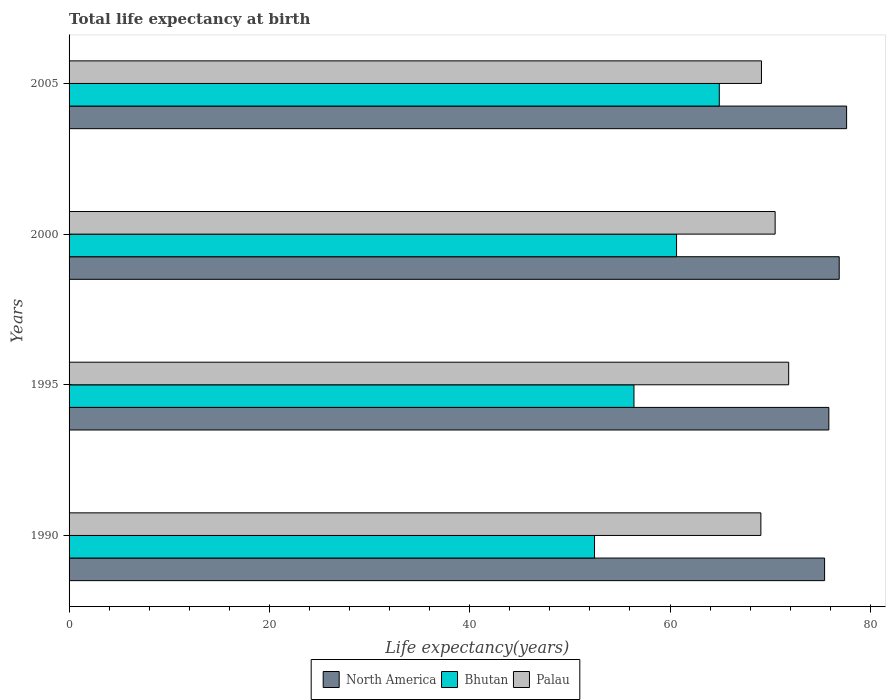Are the number of bars on each tick of the Y-axis equal?
Your answer should be very brief. Yes. What is the life expectancy at birth in in Bhutan in 1995?
Your answer should be very brief. 56.4. Across all years, what is the maximum life expectancy at birth in in Palau?
Ensure brevity in your answer.  71.84. Across all years, what is the minimum life expectancy at birth in in Palau?
Your answer should be very brief. 69.07. In which year was the life expectancy at birth in in North America maximum?
Make the answer very short. 2005. In which year was the life expectancy at birth in in North America minimum?
Make the answer very short. 1990. What is the total life expectancy at birth in in North America in the graph?
Your answer should be compact. 305.81. What is the difference between the life expectancy at birth in in Palau in 1990 and that in 2000?
Your response must be concise. -1.42. What is the difference between the life expectancy at birth in in Palau in 1990 and the life expectancy at birth in in Bhutan in 2005?
Offer a terse response. 4.15. What is the average life expectancy at birth in in Bhutan per year?
Offer a terse response. 58.61. In the year 1990, what is the difference between the life expectancy at birth in in North America and life expectancy at birth in in Bhutan?
Your answer should be compact. 22.97. What is the ratio of the life expectancy at birth in in Palau in 2000 to that in 2005?
Keep it short and to the point. 1.02. Is the life expectancy at birth in in Palau in 1995 less than that in 2000?
Your answer should be very brief. No. What is the difference between the highest and the second highest life expectancy at birth in in North America?
Give a very brief answer. 0.74. What is the difference between the highest and the lowest life expectancy at birth in in North America?
Give a very brief answer. 2.2. In how many years, is the life expectancy at birth in in Palau greater than the average life expectancy at birth in in Palau taken over all years?
Offer a very short reply. 2. Is the sum of the life expectancy at birth in in North America in 2000 and 2005 greater than the maximum life expectancy at birth in in Bhutan across all years?
Provide a short and direct response. Yes. Is it the case that in every year, the sum of the life expectancy at birth in in Palau and life expectancy at birth in in North America is greater than the life expectancy at birth in in Bhutan?
Your response must be concise. Yes. Does the graph contain any zero values?
Your answer should be compact. No. Does the graph contain grids?
Ensure brevity in your answer.  No. How many legend labels are there?
Your response must be concise. 3. How are the legend labels stacked?
Provide a succinct answer. Horizontal. What is the title of the graph?
Provide a short and direct response. Total life expectancy at birth. What is the label or title of the X-axis?
Ensure brevity in your answer.  Life expectancy(years). What is the Life expectancy(years) of North America in 1990?
Offer a very short reply. 75.43. What is the Life expectancy(years) of Bhutan in 1990?
Provide a short and direct response. 52.46. What is the Life expectancy(years) of Palau in 1990?
Your answer should be very brief. 69.07. What is the Life expectancy(years) in North America in 1995?
Provide a short and direct response. 75.86. What is the Life expectancy(years) of Bhutan in 1995?
Make the answer very short. 56.4. What is the Life expectancy(years) of Palau in 1995?
Provide a short and direct response. 71.84. What is the Life expectancy(years) of North America in 2000?
Provide a succinct answer. 76.89. What is the Life expectancy(years) in Bhutan in 2000?
Offer a terse response. 60.65. What is the Life expectancy(years) in Palau in 2000?
Provide a short and direct response. 70.49. What is the Life expectancy(years) of North America in 2005?
Your response must be concise. 77.63. What is the Life expectancy(years) of Bhutan in 2005?
Your answer should be very brief. 64.92. What is the Life expectancy(years) in Palau in 2005?
Your response must be concise. 69.13. Across all years, what is the maximum Life expectancy(years) of North America?
Provide a succinct answer. 77.63. Across all years, what is the maximum Life expectancy(years) in Bhutan?
Offer a terse response. 64.92. Across all years, what is the maximum Life expectancy(years) of Palau?
Your answer should be compact. 71.84. Across all years, what is the minimum Life expectancy(years) of North America?
Your response must be concise. 75.43. Across all years, what is the minimum Life expectancy(years) in Bhutan?
Provide a succinct answer. 52.46. Across all years, what is the minimum Life expectancy(years) in Palau?
Ensure brevity in your answer.  69.07. What is the total Life expectancy(years) of North America in the graph?
Provide a short and direct response. 305.81. What is the total Life expectancy(years) in Bhutan in the graph?
Make the answer very short. 234.43. What is the total Life expectancy(years) in Palau in the graph?
Your answer should be compact. 280.54. What is the difference between the Life expectancy(years) in North America in 1990 and that in 1995?
Your answer should be very brief. -0.42. What is the difference between the Life expectancy(years) of Bhutan in 1990 and that in 1995?
Ensure brevity in your answer.  -3.94. What is the difference between the Life expectancy(years) in Palau in 1990 and that in 1995?
Offer a terse response. -2.78. What is the difference between the Life expectancy(years) in North America in 1990 and that in 2000?
Your answer should be compact. -1.46. What is the difference between the Life expectancy(years) of Bhutan in 1990 and that in 2000?
Offer a very short reply. -8.19. What is the difference between the Life expectancy(years) in Palau in 1990 and that in 2000?
Provide a short and direct response. -1.42. What is the difference between the Life expectancy(years) of North America in 1990 and that in 2005?
Your answer should be very brief. -2.2. What is the difference between the Life expectancy(years) in Bhutan in 1990 and that in 2005?
Ensure brevity in your answer.  -12.46. What is the difference between the Life expectancy(years) in Palau in 1990 and that in 2005?
Provide a succinct answer. -0.06. What is the difference between the Life expectancy(years) of North America in 1995 and that in 2000?
Your response must be concise. -1.04. What is the difference between the Life expectancy(years) in Bhutan in 1995 and that in 2000?
Give a very brief answer. -4.25. What is the difference between the Life expectancy(years) of Palau in 1995 and that in 2000?
Give a very brief answer. 1.35. What is the difference between the Life expectancy(years) of North America in 1995 and that in 2005?
Ensure brevity in your answer.  -1.77. What is the difference between the Life expectancy(years) of Bhutan in 1995 and that in 2005?
Make the answer very short. -8.52. What is the difference between the Life expectancy(years) of Palau in 1995 and that in 2005?
Offer a terse response. 2.72. What is the difference between the Life expectancy(years) of North America in 2000 and that in 2005?
Your answer should be compact. -0.74. What is the difference between the Life expectancy(years) in Bhutan in 2000 and that in 2005?
Provide a short and direct response. -4.27. What is the difference between the Life expectancy(years) in Palau in 2000 and that in 2005?
Your response must be concise. 1.36. What is the difference between the Life expectancy(years) in North America in 1990 and the Life expectancy(years) in Bhutan in 1995?
Your answer should be very brief. 19.03. What is the difference between the Life expectancy(years) of North America in 1990 and the Life expectancy(years) of Palau in 1995?
Offer a terse response. 3.59. What is the difference between the Life expectancy(years) in Bhutan in 1990 and the Life expectancy(years) in Palau in 1995?
Make the answer very short. -19.38. What is the difference between the Life expectancy(years) in North America in 1990 and the Life expectancy(years) in Bhutan in 2000?
Your answer should be compact. 14.78. What is the difference between the Life expectancy(years) in North America in 1990 and the Life expectancy(years) in Palau in 2000?
Give a very brief answer. 4.94. What is the difference between the Life expectancy(years) of Bhutan in 1990 and the Life expectancy(years) of Palau in 2000?
Ensure brevity in your answer.  -18.03. What is the difference between the Life expectancy(years) in North America in 1990 and the Life expectancy(years) in Bhutan in 2005?
Provide a short and direct response. 10.51. What is the difference between the Life expectancy(years) of North America in 1990 and the Life expectancy(years) of Palau in 2005?
Your answer should be compact. 6.3. What is the difference between the Life expectancy(years) of Bhutan in 1990 and the Life expectancy(years) of Palau in 2005?
Provide a succinct answer. -16.67. What is the difference between the Life expectancy(years) of North America in 1995 and the Life expectancy(years) of Bhutan in 2000?
Offer a terse response. 15.21. What is the difference between the Life expectancy(years) of North America in 1995 and the Life expectancy(years) of Palau in 2000?
Provide a short and direct response. 5.36. What is the difference between the Life expectancy(years) of Bhutan in 1995 and the Life expectancy(years) of Palau in 2000?
Give a very brief answer. -14.09. What is the difference between the Life expectancy(years) of North America in 1995 and the Life expectancy(years) of Bhutan in 2005?
Your answer should be very brief. 10.94. What is the difference between the Life expectancy(years) of North America in 1995 and the Life expectancy(years) of Palau in 2005?
Give a very brief answer. 6.73. What is the difference between the Life expectancy(years) of Bhutan in 1995 and the Life expectancy(years) of Palau in 2005?
Make the answer very short. -12.73. What is the difference between the Life expectancy(years) of North America in 2000 and the Life expectancy(years) of Bhutan in 2005?
Your response must be concise. 11.97. What is the difference between the Life expectancy(years) in North America in 2000 and the Life expectancy(years) in Palau in 2005?
Your answer should be very brief. 7.76. What is the difference between the Life expectancy(years) of Bhutan in 2000 and the Life expectancy(years) of Palau in 2005?
Give a very brief answer. -8.48. What is the average Life expectancy(years) of North America per year?
Your response must be concise. 76.45. What is the average Life expectancy(years) of Bhutan per year?
Offer a terse response. 58.61. What is the average Life expectancy(years) of Palau per year?
Provide a short and direct response. 70.13. In the year 1990, what is the difference between the Life expectancy(years) in North America and Life expectancy(years) in Bhutan?
Offer a very short reply. 22.97. In the year 1990, what is the difference between the Life expectancy(years) in North America and Life expectancy(years) in Palau?
Offer a terse response. 6.36. In the year 1990, what is the difference between the Life expectancy(years) in Bhutan and Life expectancy(years) in Palau?
Provide a short and direct response. -16.61. In the year 1995, what is the difference between the Life expectancy(years) of North America and Life expectancy(years) of Bhutan?
Make the answer very short. 19.46. In the year 1995, what is the difference between the Life expectancy(years) of North America and Life expectancy(years) of Palau?
Your answer should be compact. 4.01. In the year 1995, what is the difference between the Life expectancy(years) of Bhutan and Life expectancy(years) of Palau?
Keep it short and to the point. -15.44. In the year 2000, what is the difference between the Life expectancy(years) of North America and Life expectancy(years) of Bhutan?
Your response must be concise. 16.24. In the year 2000, what is the difference between the Life expectancy(years) in North America and Life expectancy(years) in Palau?
Offer a very short reply. 6.4. In the year 2000, what is the difference between the Life expectancy(years) in Bhutan and Life expectancy(years) in Palau?
Make the answer very short. -9.84. In the year 2005, what is the difference between the Life expectancy(years) of North America and Life expectancy(years) of Bhutan?
Offer a terse response. 12.71. In the year 2005, what is the difference between the Life expectancy(years) of North America and Life expectancy(years) of Palau?
Your answer should be compact. 8.5. In the year 2005, what is the difference between the Life expectancy(years) in Bhutan and Life expectancy(years) in Palau?
Provide a short and direct response. -4.21. What is the ratio of the Life expectancy(years) in North America in 1990 to that in 1995?
Offer a very short reply. 0.99. What is the ratio of the Life expectancy(years) of Bhutan in 1990 to that in 1995?
Your answer should be compact. 0.93. What is the ratio of the Life expectancy(years) of Palau in 1990 to that in 1995?
Your response must be concise. 0.96. What is the ratio of the Life expectancy(years) of North America in 1990 to that in 2000?
Your answer should be compact. 0.98. What is the ratio of the Life expectancy(years) in Bhutan in 1990 to that in 2000?
Provide a short and direct response. 0.86. What is the ratio of the Life expectancy(years) in Palau in 1990 to that in 2000?
Keep it short and to the point. 0.98. What is the ratio of the Life expectancy(years) in North America in 1990 to that in 2005?
Keep it short and to the point. 0.97. What is the ratio of the Life expectancy(years) of Bhutan in 1990 to that in 2005?
Offer a very short reply. 0.81. What is the ratio of the Life expectancy(years) in Palau in 1990 to that in 2005?
Make the answer very short. 1. What is the ratio of the Life expectancy(years) of North America in 1995 to that in 2000?
Provide a short and direct response. 0.99. What is the ratio of the Life expectancy(years) of Bhutan in 1995 to that in 2000?
Your response must be concise. 0.93. What is the ratio of the Life expectancy(years) in Palau in 1995 to that in 2000?
Your response must be concise. 1.02. What is the ratio of the Life expectancy(years) in North America in 1995 to that in 2005?
Offer a terse response. 0.98. What is the ratio of the Life expectancy(years) of Bhutan in 1995 to that in 2005?
Give a very brief answer. 0.87. What is the ratio of the Life expectancy(years) in Palau in 1995 to that in 2005?
Offer a very short reply. 1.04. What is the ratio of the Life expectancy(years) in North America in 2000 to that in 2005?
Your answer should be very brief. 0.99. What is the ratio of the Life expectancy(years) in Bhutan in 2000 to that in 2005?
Your response must be concise. 0.93. What is the ratio of the Life expectancy(years) of Palau in 2000 to that in 2005?
Give a very brief answer. 1.02. What is the difference between the highest and the second highest Life expectancy(years) of North America?
Your response must be concise. 0.74. What is the difference between the highest and the second highest Life expectancy(years) in Bhutan?
Offer a very short reply. 4.27. What is the difference between the highest and the second highest Life expectancy(years) of Palau?
Keep it short and to the point. 1.35. What is the difference between the highest and the lowest Life expectancy(years) in North America?
Give a very brief answer. 2.2. What is the difference between the highest and the lowest Life expectancy(years) in Bhutan?
Ensure brevity in your answer.  12.46. What is the difference between the highest and the lowest Life expectancy(years) in Palau?
Offer a terse response. 2.78. 